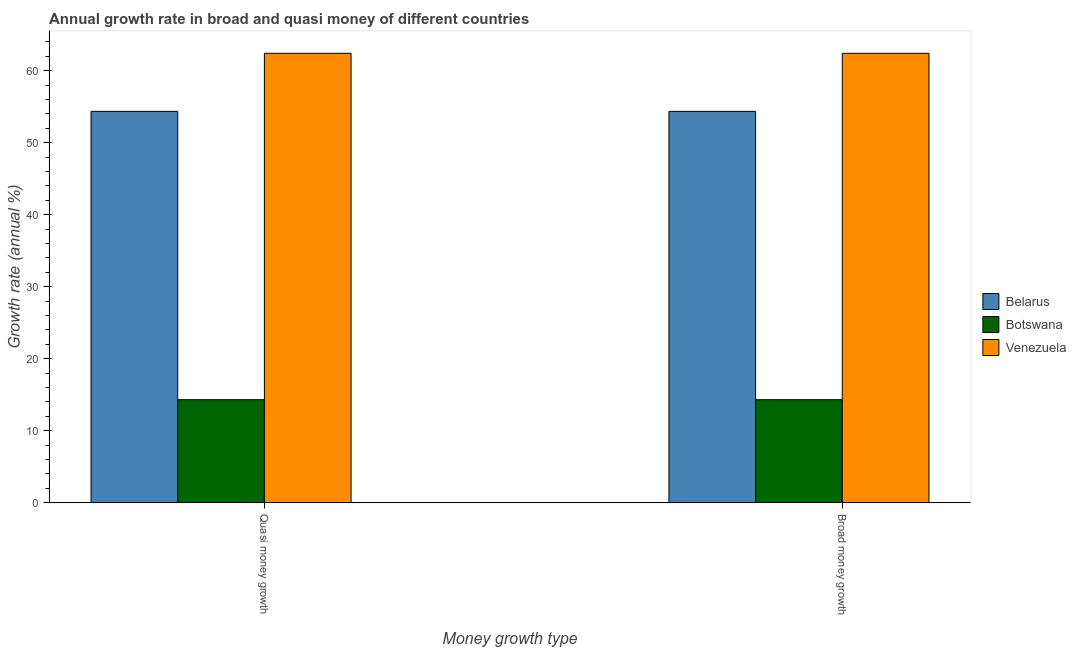How many different coloured bars are there?
Offer a terse response. 3. How many groups of bars are there?
Offer a very short reply. 2. Are the number of bars per tick equal to the number of legend labels?
Offer a terse response. Yes. How many bars are there on the 2nd tick from the left?
Offer a terse response. 3. What is the label of the 2nd group of bars from the left?
Offer a terse response. Broad money growth. What is the annual growth rate in quasi money in Botswana?
Ensure brevity in your answer.  14.31. Across all countries, what is the maximum annual growth rate in broad money?
Provide a succinct answer. 62.41. Across all countries, what is the minimum annual growth rate in broad money?
Make the answer very short. 14.31. In which country was the annual growth rate in broad money maximum?
Your response must be concise. Venezuela. In which country was the annual growth rate in quasi money minimum?
Your answer should be compact. Botswana. What is the total annual growth rate in broad money in the graph?
Give a very brief answer. 131.07. What is the difference between the annual growth rate in quasi money in Venezuela and that in Belarus?
Offer a very short reply. 8.06. What is the difference between the annual growth rate in broad money in Belarus and the annual growth rate in quasi money in Venezuela?
Provide a short and direct response. -8.06. What is the average annual growth rate in broad money per country?
Offer a terse response. 43.69. What is the difference between the annual growth rate in quasi money and annual growth rate in broad money in Botswana?
Offer a terse response. 0. In how many countries, is the annual growth rate in broad money greater than 14 %?
Provide a short and direct response. 3. What is the ratio of the annual growth rate in broad money in Botswana to that in Belarus?
Offer a terse response. 0.26. What does the 3rd bar from the left in Broad money growth represents?
Provide a succinct answer. Venezuela. What does the 1st bar from the right in Broad money growth represents?
Ensure brevity in your answer.  Venezuela. How many bars are there?
Offer a very short reply. 6. Are all the bars in the graph horizontal?
Your answer should be very brief. No. What is the difference between two consecutive major ticks on the Y-axis?
Keep it short and to the point. 10. What is the title of the graph?
Keep it short and to the point. Annual growth rate in broad and quasi money of different countries. Does "Guam" appear as one of the legend labels in the graph?
Provide a short and direct response. No. What is the label or title of the X-axis?
Your answer should be compact. Money growth type. What is the label or title of the Y-axis?
Offer a terse response. Growth rate (annual %). What is the Growth rate (annual %) in Belarus in Quasi money growth?
Make the answer very short. 54.35. What is the Growth rate (annual %) in Botswana in Quasi money growth?
Provide a succinct answer. 14.31. What is the Growth rate (annual %) in Venezuela in Quasi money growth?
Offer a terse response. 62.41. What is the Growth rate (annual %) in Belarus in Broad money growth?
Ensure brevity in your answer.  54.35. What is the Growth rate (annual %) of Botswana in Broad money growth?
Make the answer very short. 14.31. What is the Growth rate (annual %) in Venezuela in Broad money growth?
Keep it short and to the point. 62.41. Across all Money growth type, what is the maximum Growth rate (annual %) in Belarus?
Ensure brevity in your answer.  54.35. Across all Money growth type, what is the maximum Growth rate (annual %) in Botswana?
Your answer should be very brief. 14.31. Across all Money growth type, what is the maximum Growth rate (annual %) in Venezuela?
Make the answer very short. 62.41. Across all Money growth type, what is the minimum Growth rate (annual %) in Belarus?
Your response must be concise. 54.35. Across all Money growth type, what is the minimum Growth rate (annual %) in Botswana?
Offer a terse response. 14.31. Across all Money growth type, what is the minimum Growth rate (annual %) in Venezuela?
Your answer should be compact. 62.41. What is the total Growth rate (annual %) in Belarus in the graph?
Your response must be concise. 108.69. What is the total Growth rate (annual %) of Botswana in the graph?
Provide a succinct answer. 28.63. What is the total Growth rate (annual %) in Venezuela in the graph?
Keep it short and to the point. 124.81. What is the difference between the Growth rate (annual %) of Botswana in Quasi money growth and that in Broad money growth?
Your answer should be very brief. 0. What is the difference between the Growth rate (annual %) of Belarus in Quasi money growth and the Growth rate (annual %) of Botswana in Broad money growth?
Your answer should be very brief. 40.03. What is the difference between the Growth rate (annual %) in Belarus in Quasi money growth and the Growth rate (annual %) in Venezuela in Broad money growth?
Offer a very short reply. -8.06. What is the difference between the Growth rate (annual %) of Botswana in Quasi money growth and the Growth rate (annual %) of Venezuela in Broad money growth?
Offer a terse response. -48.09. What is the average Growth rate (annual %) in Belarus per Money growth type?
Your answer should be compact. 54.35. What is the average Growth rate (annual %) of Botswana per Money growth type?
Make the answer very short. 14.31. What is the average Growth rate (annual %) in Venezuela per Money growth type?
Your answer should be very brief. 62.41. What is the difference between the Growth rate (annual %) of Belarus and Growth rate (annual %) of Botswana in Quasi money growth?
Your answer should be very brief. 40.03. What is the difference between the Growth rate (annual %) in Belarus and Growth rate (annual %) in Venezuela in Quasi money growth?
Provide a succinct answer. -8.06. What is the difference between the Growth rate (annual %) in Botswana and Growth rate (annual %) in Venezuela in Quasi money growth?
Offer a very short reply. -48.09. What is the difference between the Growth rate (annual %) of Belarus and Growth rate (annual %) of Botswana in Broad money growth?
Your response must be concise. 40.03. What is the difference between the Growth rate (annual %) of Belarus and Growth rate (annual %) of Venezuela in Broad money growth?
Offer a terse response. -8.06. What is the difference between the Growth rate (annual %) of Botswana and Growth rate (annual %) of Venezuela in Broad money growth?
Offer a very short reply. -48.09. What is the ratio of the Growth rate (annual %) in Belarus in Quasi money growth to that in Broad money growth?
Your answer should be very brief. 1. What is the ratio of the Growth rate (annual %) in Venezuela in Quasi money growth to that in Broad money growth?
Your response must be concise. 1. What is the difference between the highest and the second highest Growth rate (annual %) in Venezuela?
Your response must be concise. 0. What is the difference between the highest and the lowest Growth rate (annual %) of Venezuela?
Provide a succinct answer. 0. 